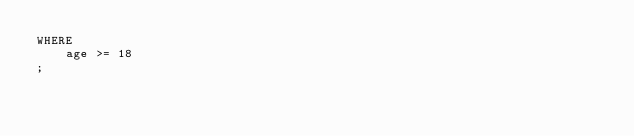Convert code to text. <code><loc_0><loc_0><loc_500><loc_500><_SQL_>WHERE
    age >= 18
;
</code> 